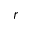<formula> <loc_0><loc_0><loc_500><loc_500>r</formula> 